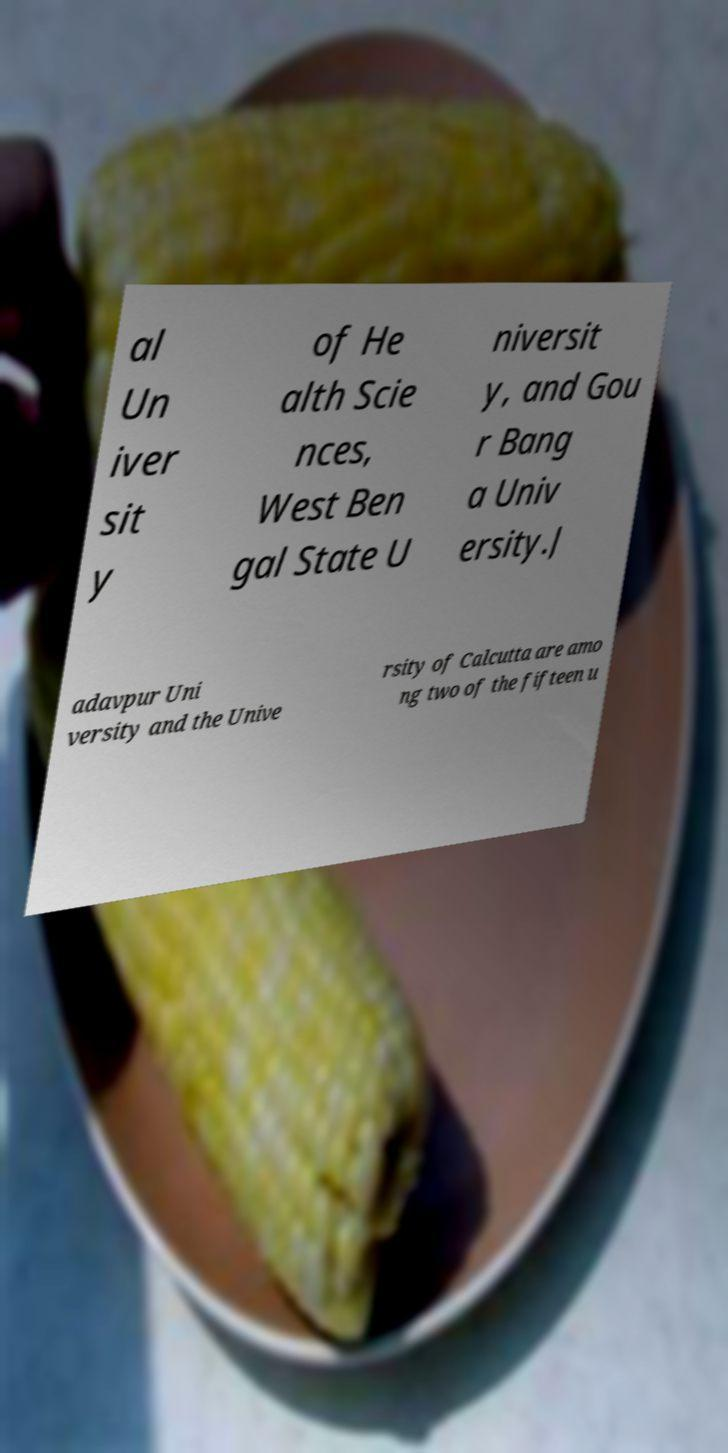Please identify and transcribe the text found in this image. al Un iver sit y of He alth Scie nces, West Ben gal State U niversit y, and Gou r Bang a Univ ersity.J adavpur Uni versity and the Unive rsity of Calcutta are amo ng two of the fifteen u 